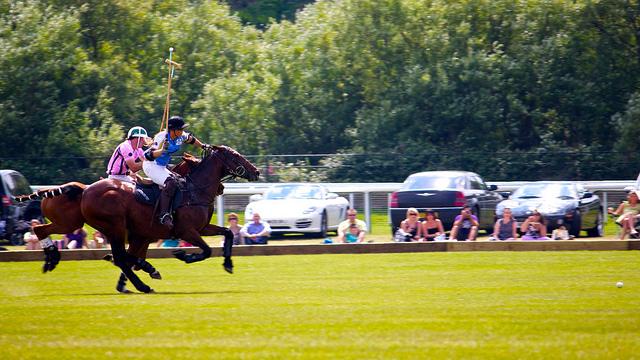Are the animals in this photo well trained?
Short answer required. Yes. Why are the horse running?
Answer briefly. Playing polo. Who will get to the ball first?
Keep it brief. Man in blue. 